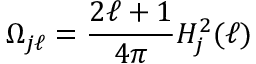Convert formula to latex. <formula><loc_0><loc_0><loc_500><loc_500>\Omega _ { j \ell } = \frac { 2 \ell + 1 } { 4 \pi } H _ { j } ^ { 2 } ( \ell )</formula> 